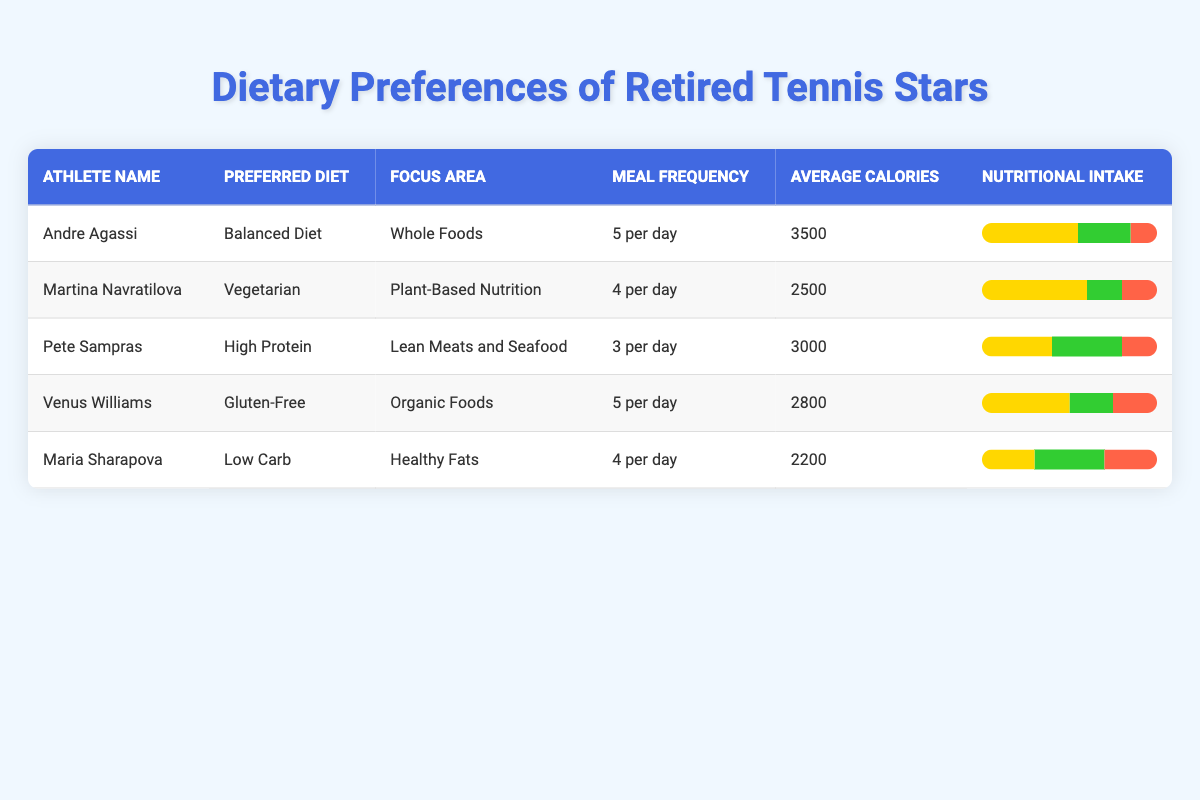What is the preferred diet of Venus Williams? Venus Williams' preferred diet is listed in the table. By looking at the row for Venus Williams, we can see that it states "Gluten-Free".
Answer: Gluten-Free How many meals does Pete Sampras have per day? In the row corresponding to Pete Sampras, the column for "Meal Frequency" indicates that he has "3 per day".
Answer: 3 per day Which athlete has the highest average calorie intake? We need to compare the average calorie intake for all athletes. The highest intake of calories is noted for Andre Agassi with "3500".
Answer: 3500 What percentage of carbohydrates does Martina Navratilova consume? The table shows the nutritional intake for each athlete. For Martina Navratilova, it indicates "60%" carbohydrates.
Answer: 60% Is Maria Sharapova's diet vegetarian? Checking the "Preferred Diet" section for Maria Sharapova reveals that her diet is "Low Carb". Since "Low Carb" does not indicate that it is vegetarian, the answer is no.
Answer: No What is the average calorie intake of all athletes listed in the table? To calculate the average, sum the average calories of all athletes: (3500 + 2500 + 3000 + 2800 + 2200) = 14000. Dividing by the total number of athletes (5) gives 14000 / 5 = 2800.
Answer: 2800 Which athlete has the lowest percentage of fats in their nutritional intake? To find this, we compare the fat percentages from each athlete. Maria Sharapova has "30%", which is lower than all others: Andre Agassi (15%), Martina Navratilova (20%), Pete Sampras (20%), and Venus Williams (25%).
Answer: 15% What is the primary focus area for Pete Sampras? Referring to the table under Pete Sampras' row, the "Focus Area" indicates "Lean Meats and Seafood". This answers the question of his focus area.
Answer: Lean Meats and Seafood Do any of the athletes have a meal frequency of less than 4 meals per day? Checking the meal frequencies listed reveals that only Pete Sampras has "3 per day", indicating yes, there is an athlete who meets this criterion.
Answer: Yes 